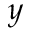Convert formula to latex. <formula><loc_0><loc_0><loc_500><loc_500>y</formula> 